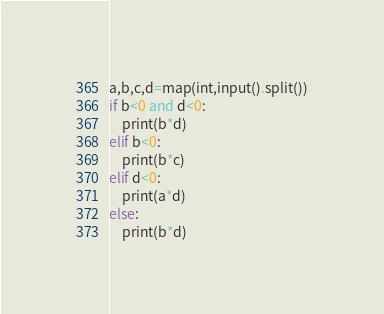<code> <loc_0><loc_0><loc_500><loc_500><_Python_>a,b,c,d=map(int,input().split())
if b<0 and d<0:
    print(b*d)
elif b<0:
    print(b*c)
elif d<0:
    print(a*d)
else:
    print(b*d)</code> 